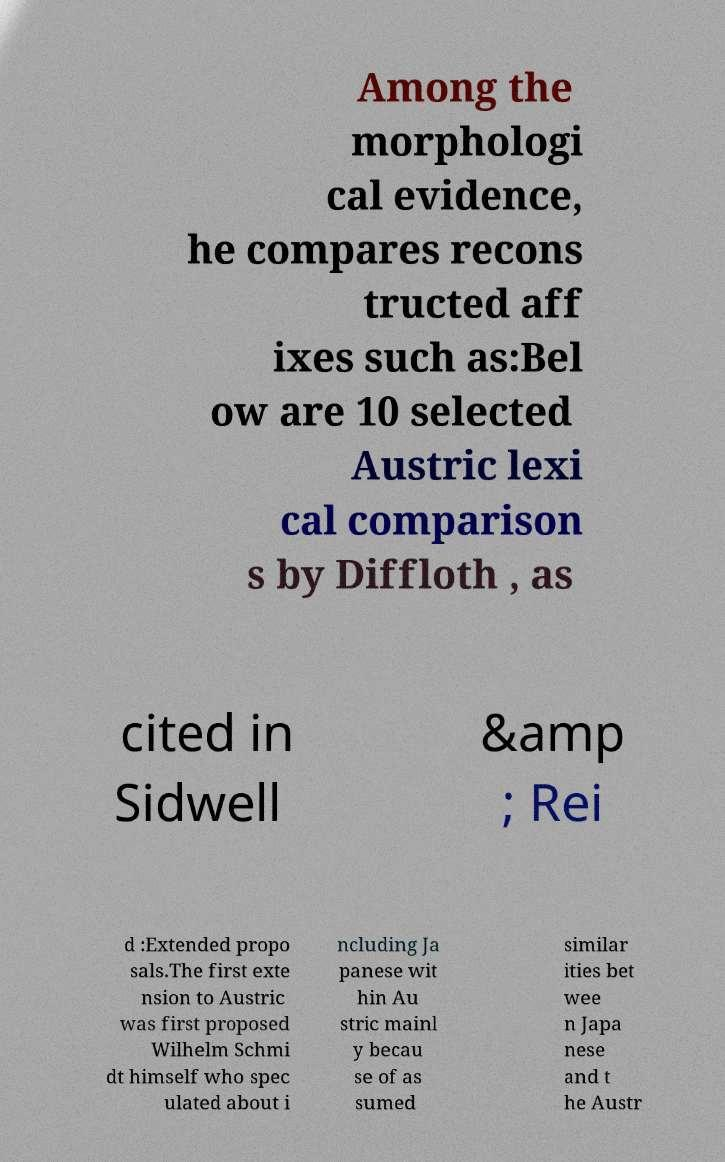I need the written content from this picture converted into text. Can you do that? Among the morphologi cal evidence, he compares recons tructed aff ixes such as:Bel ow are 10 selected Austric lexi cal comparison s by Diffloth , as cited in Sidwell &amp ; Rei d :Extended propo sals.The first exte nsion to Austric was first proposed Wilhelm Schmi dt himself who spec ulated about i ncluding Ja panese wit hin Au stric mainl y becau se of as sumed similar ities bet wee n Japa nese and t he Austr 